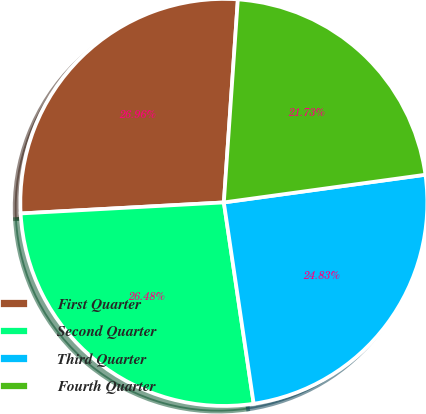<chart> <loc_0><loc_0><loc_500><loc_500><pie_chart><fcel>First Quarter<fcel>Second Quarter<fcel>Third Quarter<fcel>Fourth Quarter<nl><fcel>26.96%<fcel>26.48%<fcel>24.83%<fcel>21.73%<nl></chart> 